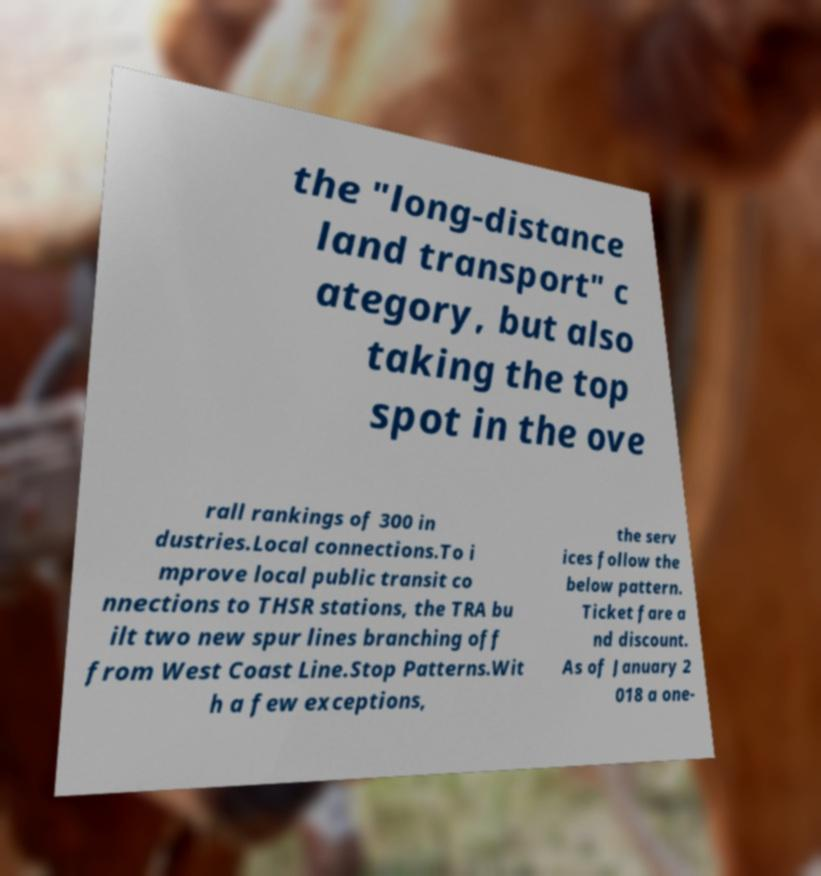I need the written content from this picture converted into text. Can you do that? the "long-distance land transport" c ategory, but also taking the top spot in the ove rall rankings of 300 in dustries.Local connections.To i mprove local public transit co nnections to THSR stations, the TRA bu ilt two new spur lines branching off from West Coast Line.Stop Patterns.Wit h a few exceptions, the serv ices follow the below pattern. Ticket fare a nd discount. As of January 2 018 a one- 